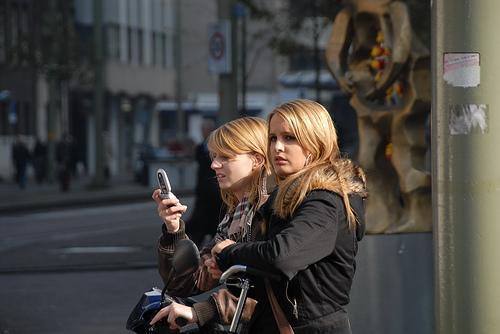How many women are pictured?
Give a very brief answer. 2. How many people can you see?
Give a very brief answer. 2. 